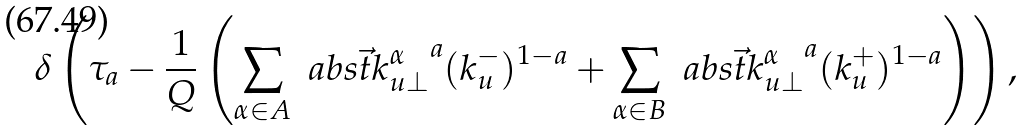<formula> <loc_0><loc_0><loc_500><loc_500>\delta \left ( \tau _ { a } - \frac { 1 } { Q } \left ( \sum _ { \alpha \in A } \ a b s { \vec { t } { k } _ { u \perp } ^ { \alpha } } ^ { a } ( k _ { u } ^ { - } ) ^ { 1 - a } + \sum _ { \alpha \in B } \ a b s { \vec { t } { k } _ { u \perp } ^ { \alpha } } ^ { a } ( k _ { u } ^ { + } ) ^ { 1 - a } \right ) \right ) ,</formula> 